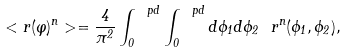<formula> <loc_0><loc_0><loc_500><loc_500>< r ( \varphi ) ^ { n } > = \frac { 4 } { \pi ^ { 2 } } \int _ { 0 } ^ { \ p d } \int _ { 0 } ^ { \ p d } d \phi _ { 1 } d \phi _ { 2 } \ r ^ { n } ( \phi _ { 1 } , \phi _ { 2 } ) ,</formula> 